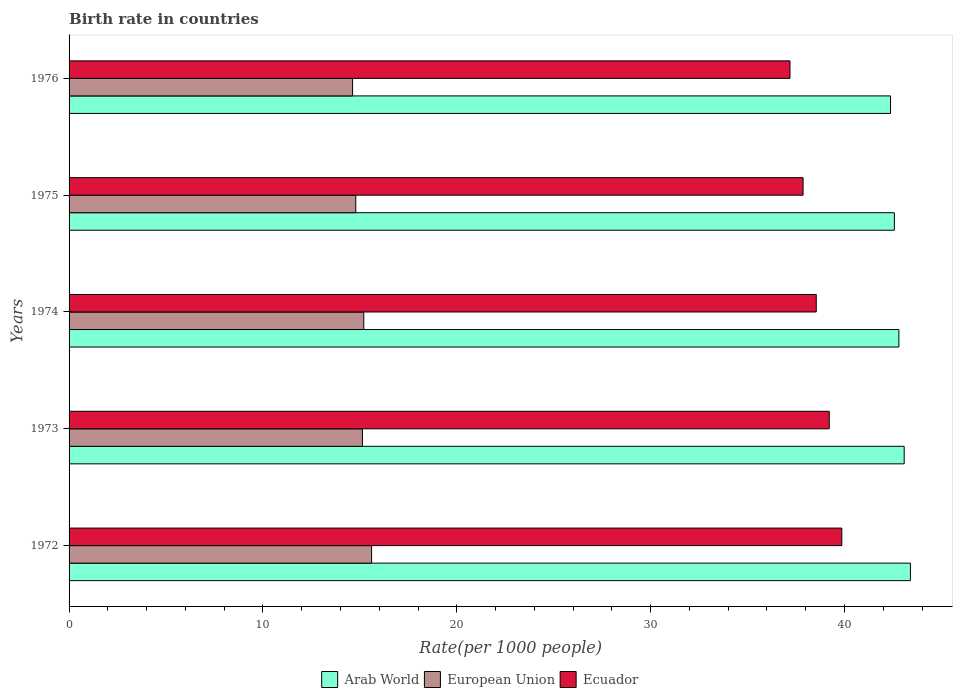How many groups of bars are there?
Make the answer very short. 5. How many bars are there on the 2nd tick from the top?
Give a very brief answer. 3. What is the label of the 3rd group of bars from the top?
Offer a very short reply. 1974. What is the birth rate in European Union in 1973?
Provide a succinct answer. 15.13. Across all years, what is the maximum birth rate in Ecuador?
Ensure brevity in your answer.  39.86. Across all years, what is the minimum birth rate in Arab World?
Your answer should be compact. 42.38. In which year was the birth rate in European Union maximum?
Your answer should be compact. 1972. In which year was the birth rate in Ecuador minimum?
Your answer should be very brief. 1976. What is the total birth rate in European Union in the graph?
Make the answer very short. 75.36. What is the difference between the birth rate in Arab World in 1972 and that in 1976?
Offer a terse response. 1.03. What is the difference between the birth rate in Ecuador in 1974 and the birth rate in European Union in 1972?
Provide a short and direct response. 22.94. What is the average birth rate in Arab World per year?
Provide a short and direct response. 42.85. In the year 1974, what is the difference between the birth rate in Arab World and birth rate in Ecuador?
Offer a terse response. 4.26. What is the ratio of the birth rate in Arab World in 1973 to that in 1974?
Your answer should be compact. 1.01. Is the birth rate in Ecuador in 1975 less than that in 1976?
Your answer should be very brief. No. Is the difference between the birth rate in Arab World in 1973 and 1976 greater than the difference between the birth rate in Ecuador in 1973 and 1976?
Offer a very short reply. No. What is the difference between the highest and the second highest birth rate in Ecuador?
Ensure brevity in your answer.  0.65. What is the difference between the highest and the lowest birth rate in European Union?
Keep it short and to the point. 0.98. Is the sum of the birth rate in Arab World in 1972 and 1976 greater than the maximum birth rate in European Union across all years?
Ensure brevity in your answer.  Yes. What does the 2nd bar from the bottom in 1976 represents?
Provide a short and direct response. European Union. Is it the case that in every year, the sum of the birth rate in Arab World and birth rate in Ecuador is greater than the birth rate in European Union?
Provide a succinct answer. Yes. How many bars are there?
Provide a succinct answer. 15. How many years are there in the graph?
Keep it short and to the point. 5. What is the difference between two consecutive major ticks on the X-axis?
Give a very brief answer. 10. Are the values on the major ticks of X-axis written in scientific E-notation?
Your response must be concise. No. Does the graph contain any zero values?
Offer a terse response. No. What is the title of the graph?
Ensure brevity in your answer.  Birth rate in countries. What is the label or title of the X-axis?
Make the answer very short. Rate(per 1000 people). What is the label or title of the Y-axis?
Keep it short and to the point. Years. What is the Rate(per 1000 people) of Arab World in 1972?
Your response must be concise. 43.4. What is the Rate(per 1000 people) of European Union in 1972?
Keep it short and to the point. 15.61. What is the Rate(per 1000 people) of Ecuador in 1972?
Make the answer very short. 39.86. What is the Rate(per 1000 people) of Arab World in 1973?
Make the answer very short. 43.08. What is the Rate(per 1000 people) in European Union in 1973?
Give a very brief answer. 15.13. What is the Rate(per 1000 people) of Ecuador in 1973?
Provide a succinct answer. 39.22. What is the Rate(per 1000 people) of Arab World in 1974?
Offer a terse response. 42.81. What is the Rate(per 1000 people) in European Union in 1974?
Give a very brief answer. 15.2. What is the Rate(per 1000 people) of Ecuador in 1974?
Offer a very short reply. 38.54. What is the Rate(per 1000 people) in Arab World in 1975?
Make the answer very short. 42.57. What is the Rate(per 1000 people) of European Union in 1975?
Offer a terse response. 14.79. What is the Rate(per 1000 people) in Ecuador in 1975?
Your answer should be very brief. 37.87. What is the Rate(per 1000 people) in Arab World in 1976?
Keep it short and to the point. 42.38. What is the Rate(per 1000 people) in European Union in 1976?
Your response must be concise. 14.63. What is the Rate(per 1000 people) in Ecuador in 1976?
Keep it short and to the point. 37.19. Across all years, what is the maximum Rate(per 1000 people) of Arab World?
Offer a terse response. 43.4. Across all years, what is the maximum Rate(per 1000 people) in European Union?
Your answer should be very brief. 15.61. Across all years, what is the maximum Rate(per 1000 people) in Ecuador?
Offer a very short reply. 39.86. Across all years, what is the minimum Rate(per 1000 people) of Arab World?
Your answer should be very brief. 42.38. Across all years, what is the minimum Rate(per 1000 people) of European Union?
Your answer should be compact. 14.63. Across all years, what is the minimum Rate(per 1000 people) in Ecuador?
Provide a short and direct response. 37.19. What is the total Rate(per 1000 people) of Arab World in the graph?
Offer a very short reply. 214.24. What is the total Rate(per 1000 people) in European Union in the graph?
Provide a short and direct response. 75.36. What is the total Rate(per 1000 people) of Ecuador in the graph?
Offer a very short reply. 192.68. What is the difference between the Rate(per 1000 people) of Arab World in 1972 and that in 1973?
Make the answer very short. 0.32. What is the difference between the Rate(per 1000 people) in European Union in 1972 and that in 1973?
Give a very brief answer. 0.47. What is the difference between the Rate(per 1000 people) of Ecuador in 1972 and that in 1973?
Offer a terse response. 0.65. What is the difference between the Rate(per 1000 people) of Arab World in 1972 and that in 1974?
Provide a succinct answer. 0.6. What is the difference between the Rate(per 1000 people) of European Union in 1972 and that in 1974?
Offer a very short reply. 0.4. What is the difference between the Rate(per 1000 people) in Ecuador in 1972 and that in 1974?
Your answer should be compact. 1.32. What is the difference between the Rate(per 1000 people) of Arab World in 1972 and that in 1975?
Provide a short and direct response. 0.83. What is the difference between the Rate(per 1000 people) in European Union in 1972 and that in 1975?
Keep it short and to the point. 0.82. What is the difference between the Rate(per 1000 people) in Ecuador in 1972 and that in 1975?
Offer a very short reply. 2. What is the difference between the Rate(per 1000 people) of Arab World in 1972 and that in 1976?
Provide a short and direct response. 1.03. What is the difference between the Rate(per 1000 people) in European Union in 1972 and that in 1976?
Provide a short and direct response. 0.98. What is the difference between the Rate(per 1000 people) of Ecuador in 1972 and that in 1976?
Offer a terse response. 2.67. What is the difference between the Rate(per 1000 people) in Arab World in 1973 and that in 1974?
Ensure brevity in your answer.  0.27. What is the difference between the Rate(per 1000 people) of European Union in 1973 and that in 1974?
Your answer should be compact. -0.07. What is the difference between the Rate(per 1000 people) of Ecuador in 1973 and that in 1974?
Ensure brevity in your answer.  0.67. What is the difference between the Rate(per 1000 people) in Arab World in 1973 and that in 1975?
Ensure brevity in your answer.  0.51. What is the difference between the Rate(per 1000 people) of European Union in 1973 and that in 1975?
Offer a very short reply. 0.34. What is the difference between the Rate(per 1000 people) of Ecuador in 1973 and that in 1975?
Ensure brevity in your answer.  1.35. What is the difference between the Rate(per 1000 people) of Arab World in 1973 and that in 1976?
Give a very brief answer. 0.71. What is the difference between the Rate(per 1000 people) in European Union in 1973 and that in 1976?
Give a very brief answer. 0.51. What is the difference between the Rate(per 1000 people) in Ecuador in 1973 and that in 1976?
Offer a terse response. 2.03. What is the difference between the Rate(per 1000 people) in Arab World in 1974 and that in 1975?
Ensure brevity in your answer.  0.23. What is the difference between the Rate(per 1000 people) in European Union in 1974 and that in 1975?
Offer a terse response. 0.41. What is the difference between the Rate(per 1000 people) of Ecuador in 1974 and that in 1975?
Offer a terse response. 0.68. What is the difference between the Rate(per 1000 people) of Arab World in 1974 and that in 1976?
Ensure brevity in your answer.  0.43. What is the difference between the Rate(per 1000 people) in European Union in 1974 and that in 1976?
Keep it short and to the point. 0.58. What is the difference between the Rate(per 1000 people) of Ecuador in 1974 and that in 1976?
Make the answer very short. 1.35. What is the difference between the Rate(per 1000 people) of Arab World in 1975 and that in 1976?
Keep it short and to the point. 0.2. What is the difference between the Rate(per 1000 people) of European Union in 1975 and that in 1976?
Keep it short and to the point. 0.16. What is the difference between the Rate(per 1000 people) in Ecuador in 1975 and that in 1976?
Keep it short and to the point. 0.68. What is the difference between the Rate(per 1000 people) of Arab World in 1972 and the Rate(per 1000 people) of European Union in 1973?
Offer a terse response. 28.27. What is the difference between the Rate(per 1000 people) in Arab World in 1972 and the Rate(per 1000 people) in Ecuador in 1973?
Your answer should be very brief. 4.19. What is the difference between the Rate(per 1000 people) in European Union in 1972 and the Rate(per 1000 people) in Ecuador in 1973?
Offer a very short reply. -23.61. What is the difference between the Rate(per 1000 people) of Arab World in 1972 and the Rate(per 1000 people) of European Union in 1974?
Your answer should be compact. 28.2. What is the difference between the Rate(per 1000 people) in Arab World in 1972 and the Rate(per 1000 people) in Ecuador in 1974?
Make the answer very short. 4.86. What is the difference between the Rate(per 1000 people) of European Union in 1972 and the Rate(per 1000 people) of Ecuador in 1974?
Provide a succinct answer. -22.94. What is the difference between the Rate(per 1000 people) in Arab World in 1972 and the Rate(per 1000 people) in European Union in 1975?
Your response must be concise. 28.61. What is the difference between the Rate(per 1000 people) in Arab World in 1972 and the Rate(per 1000 people) in Ecuador in 1975?
Offer a terse response. 5.54. What is the difference between the Rate(per 1000 people) in European Union in 1972 and the Rate(per 1000 people) in Ecuador in 1975?
Your response must be concise. -22.26. What is the difference between the Rate(per 1000 people) in Arab World in 1972 and the Rate(per 1000 people) in European Union in 1976?
Provide a succinct answer. 28.78. What is the difference between the Rate(per 1000 people) of Arab World in 1972 and the Rate(per 1000 people) of Ecuador in 1976?
Your answer should be compact. 6.21. What is the difference between the Rate(per 1000 people) in European Union in 1972 and the Rate(per 1000 people) in Ecuador in 1976?
Keep it short and to the point. -21.58. What is the difference between the Rate(per 1000 people) of Arab World in 1973 and the Rate(per 1000 people) of European Union in 1974?
Offer a terse response. 27.88. What is the difference between the Rate(per 1000 people) in Arab World in 1973 and the Rate(per 1000 people) in Ecuador in 1974?
Make the answer very short. 4.54. What is the difference between the Rate(per 1000 people) of European Union in 1973 and the Rate(per 1000 people) of Ecuador in 1974?
Make the answer very short. -23.41. What is the difference between the Rate(per 1000 people) in Arab World in 1973 and the Rate(per 1000 people) in European Union in 1975?
Your response must be concise. 28.29. What is the difference between the Rate(per 1000 people) of Arab World in 1973 and the Rate(per 1000 people) of Ecuador in 1975?
Ensure brevity in your answer.  5.22. What is the difference between the Rate(per 1000 people) of European Union in 1973 and the Rate(per 1000 people) of Ecuador in 1975?
Offer a very short reply. -22.73. What is the difference between the Rate(per 1000 people) in Arab World in 1973 and the Rate(per 1000 people) in European Union in 1976?
Offer a very short reply. 28.46. What is the difference between the Rate(per 1000 people) of Arab World in 1973 and the Rate(per 1000 people) of Ecuador in 1976?
Your answer should be compact. 5.89. What is the difference between the Rate(per 1000 people) in European Union in 1973 and the Rate(per 1000 people) in Ecuador in 1976?
Your answer should be very brief. -22.05. What is the difference between the Rate(per 1000 people) of Arab World in 1974 and the Rate(per 1000 people) of European Union in 1975?
Offer a terse response. 28.02. What is the difference between the Rate(per 1000 people) of Arab World in 1974 and the Rate(per 1000 people) of Ecuador in 1975?
Your answer should be compact. 4.94. What is the difference between the Rate(per 1000 people) of European Union in 1974 and the Rate(per 1000 people) of Ecuador in 1975?
Keep it short and to the point. -22.66. What is the difference between the Rate(per 1000 people) of Arab World in 1974 and the Rate(per 1000 people) of European Union in 1976?
Your answer should be compact. 28.18. What is the difference between the Rate(per 1000 people) in Arab World in 1974 and the Rate(per 1000 people) in Ecuador in 1976?
Ensure brevity in your answer.  5.62. What is the difference between the Rate(per 1000 people) in European Union in 1974 and the Rate(per 1000 people) in Ecuador in 1976?
Provide a short and direct response. -21.99. What is the difference between the Rate(per 1000 people) of Arab World in 1975 and the Rate(per 1000 people) of European Union in 1976?
Your answer should be very brief. 27.95. What is the difference between the Rate(per 1000 people) of Arab World in 1975 and the Rate(per 1000 people) of Ecuador in 1976?
Your answer should be very brief. 5.39. What is the difference between the Rate(per 1000 people) of European Union in 1975 and the Rate(per 1000 people) of Ecuador in 1976?
Your response must be concise. -22.4. What is the average Rate(per 1000 people) of Arab World per year?
Ensure brevity in your answer.  42.85. What is the average Rate(per 1000 people) in European Union per year?
Provide a succinct answer. 15.07. What is the average Rate(per 1000 people) of Ecuador per year?
Make the answer very short. 38.54. In the year 1972, what is the difference between the Rate(per 1000 people) in Arab World and Rate(per 1000 people) in European Union?
Your response must be concise. 27.8. In the year 1972, what is the difference between the Rate(per 1000 people) of Arab World and Rate(per 1000 people) of Ecuador?
Keep it short and to the point. 3.54. In the year 1972, what is the difference between the Rate(per 1000 people) of European Union and Rate(per 1000 people) of Ecuador?
Give a very brief answer. -24.26. In the year 1973, what is the difference between the Rate(per 1000 people) in Arab World and Rate(per 1000 people) in European Union?
Keep it short and to the point. 27.95. In the year 1973, what is the difference between the Rate(per 1000 people) in Arab World and Rate(per 1000 people) in Ecuador?
Offer a very short reply. 3.87. In the year 1973, what is the difference between the Rate(per 1000 people) in European Union and Rate(per 1000 people) in Ecuador?
Make the answer very short. -24.08. In the year 1974, what is the difference between the Rate(per 1000 people) in Arab World and Rate(per 1000 people) in European Union?
Ensure brevity in your answer.  27.6. In the year 1974, what is the difference between the Rate(per 1000 people) of Arab World and Rate(per 1000 people) of Ecuador?
Ensure brevity in your answer.  4.26. In the year 1974, what is the difference between the Rate(per 1000 people) in European Union and Rate(per 1000 people) in Ecuador?
Make the answer very short. -23.34. In the year 1975, what is the difference between the Rate(per 1000 people) of Arab World and Rate(per 1000 people) of European Union?
Offer a terse response. 27.78. In the year 1975, what is the difference between the Rate(per 1000 people) of Arab World and Rate(per 1000 people) of Ecuador?
Your response must be concise. 4.71. In the year 1975, what is the difference between the Rate(per 1000 people) in European Union and Rate(per 1000 people) in Ecuador?
Your answer should be very brief. -23.08. In the year 1976, what is the difference between the Rate(per 1000 people) of Arab World and Rate(per 1000 people) of European Union?
Your answer should be very brief. 27.75. In the year 1976, what is the difference between the Rate(per 1000 people) in Arab World and Rate(per 1000 people) in Ecuador?
Your answer should be very brief. 5.19. In the year 1976, what is the difference between the Rate(per 1000 people) in European Union and Rate(per 1000 people) in Ecuador?
Provide a short and direct response. -22.56. What is the ratio of the Rate(per 1000 people) of Arab World in 1972 to that in 1973?
Provide a short and direct response. 1.01. What is the ratio of the Rate(per 1000 people) in European Union in 1972 to that in 1973?
Your answer should be compact. 1.03. What is the ratio of the Rate(per 1000 people) of Ecuador in 1972 to that in 1973?
Give a very brief answer. 1.02. What is the ratio of the Rate(per 1000 people) in Arab World in 1972 to that in 1974?
Your answer should be compact. 1.01. What is the ratio of the Rate(per 1000 people) in European Union in 1972 to that in 1974?
Provide a succinct answer. 1.03. What is the ratio of the Rate(per 1000 people) of Ecuador in 1972 to that in 1974?
Provide a short and direct response. 1.03. What is the ratio of the Rate(per 1000 people) of Arab World in 1972 to that in 1975?
Keep it short and to the point. 1.02. What is the ratio of the Rate(per 1000 people) of European Union in 1972 to that in 1975?
Keep it short and to the point. 1.06. What is the ratio of the Rate(per 1000 people) in Ecuador in 1972 to that in 1975?
Ensure brevity in your answer.  1.05. What is the ratio of the Rate(per 1000 people) in Arab World in 1972 to that in 1976?
Your response must be concise. 1.02. What is the ratio of the Rate(per 1000 people) of European Union in 1972 to that in 1976?
Provide a short and direct response. 1.07. What is the ratio of the Rate(per 1000 people) of Ecuador in 1972 to that in 1976?
Your response must be concise. 1.07. What is the ratio of the Rate(per 1000 people) in Arab World in 1973 to that in 1974?
Make the answer very short. 1.01. What is the ratio of the Rate(per 1000 people) in Ecuador in 1973 to that in 1974?
Your response must be concise. 1.02. What is the ratio of the Rate(per 1000 people) in Arab World in 1973 to that in 1975?
Your response must be concise. 1.01. What is the ratio of the Rate(per 1000 people) of European Union in 1973 to that in 1975?
Keep it short and to the point. 1.02. What is the ratio of the Rate(per 1000 people) of Ecuador in 1973 to that in 1975?
Ensure brevity in your answer.  1.04. What is the ratio of the Rate(per 1000 people) of Arab World in 1973 to that in 1976?
Offer a terse response. 1.02. What is the ratio of the Rate(per 1000 people) in European Union in 1973 to that in 1976?
Offer a very short reply. 1.03. What is the ratio of the Rate(per 1000 people) in Ecuador in 1973 to that in 1976?
Ensure brevity in your answer.  1.05. What is the ratio of the Rate(per 1000 people) of Arab World in 1974 to that in 1975?
Your response must be concise. 1.01. What is the ratio of the Rate(per 1000 people) of European Union in 1974 to that in 1975?
Make the answer very short. 1.03. What is the ratio of the Rate(per 1000 people) in Ecuador in 1974 to that in 1975?
Offer a terse response. 1.02. What is the ratio of the Rate(per 1000 people) in Arab World in 1974 to that in 1976?
Your answer should be compact. 1.01. What is the ratio of the Rate(per 1000 people) of European Union in 1974 to that in 1976?
Ensure brevity in your answer.  1.04. What is the ratio of the Rate(per 1000 people) in Ecuador in 1974 to that in 1976?
Your response must be concise. 1.04. What is the ratio of the Rate(per 1000 people) of European Union in 1975 to that in 1976?
Offer a very short reply. 1.01. What is the ratio of the Rate(per 1000 people) in Ecuador in 1975 to that in 1976?
Make the answer very short. 1.02. What is the difference between the highest and the second highest Rate(per 1000 people) of Arab World?
Make the answer very short. 0.32. What is the difference between the highest and the second highest Rate(per 1000 people) of European Union?
Make the answer very short. 0.4. What is the difference between the highest and the second highest Rate(per 1000 people) of Ecuador?
Provide a succinct answer. 0.65. What is the difference between the highest and the lowest Rate(per 1000 people) of Arab World?
Provide a succinct answer. 1.03. What is the difference between the highest and the lowest Rate(per 1000 people) in European Union?
Keep it short and to the point. 0.98. What is the difference between the highest and the lowest Rate(per 1000 people) in Ecuador?
Offer a terse response. 2.67. 